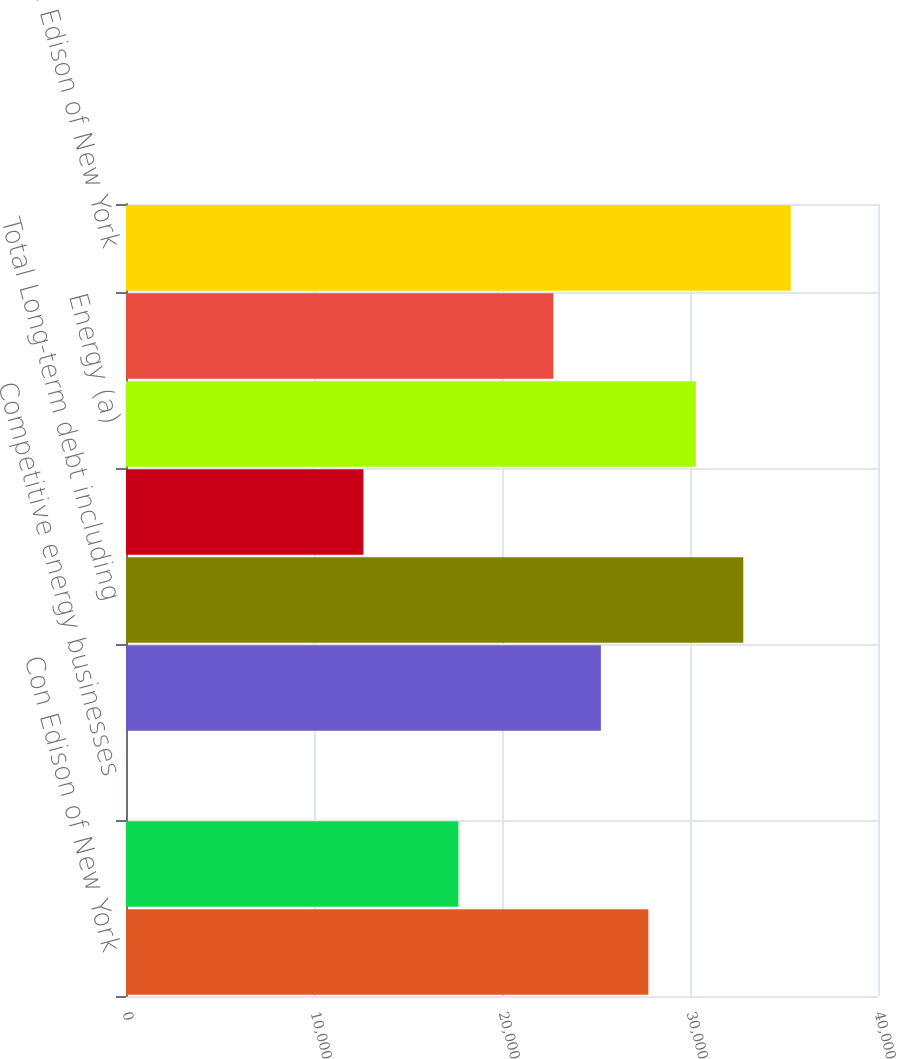Convert chart to OTSL. <chart><loc_0><loc_0><loc_500><loc_500><bar_chart><fcel>Con Edison of New York<fcel>O&R<fcel>Competitive energy businesses<fcel>Interest on long-term debt<fcel>Total Long-term debt including<fcel>Total operating leases<fcel>Energy (a)<fcel>Capacity<fcel>Total Con Edison of New York<nl><fcel>27784.6<fcel>17682.2<fcel>3<fcel>25259<fcel>32835.8<fcel>12631<fcel>30310.2<fcel>22733.4<fcel>35361.4<nl></chart> 